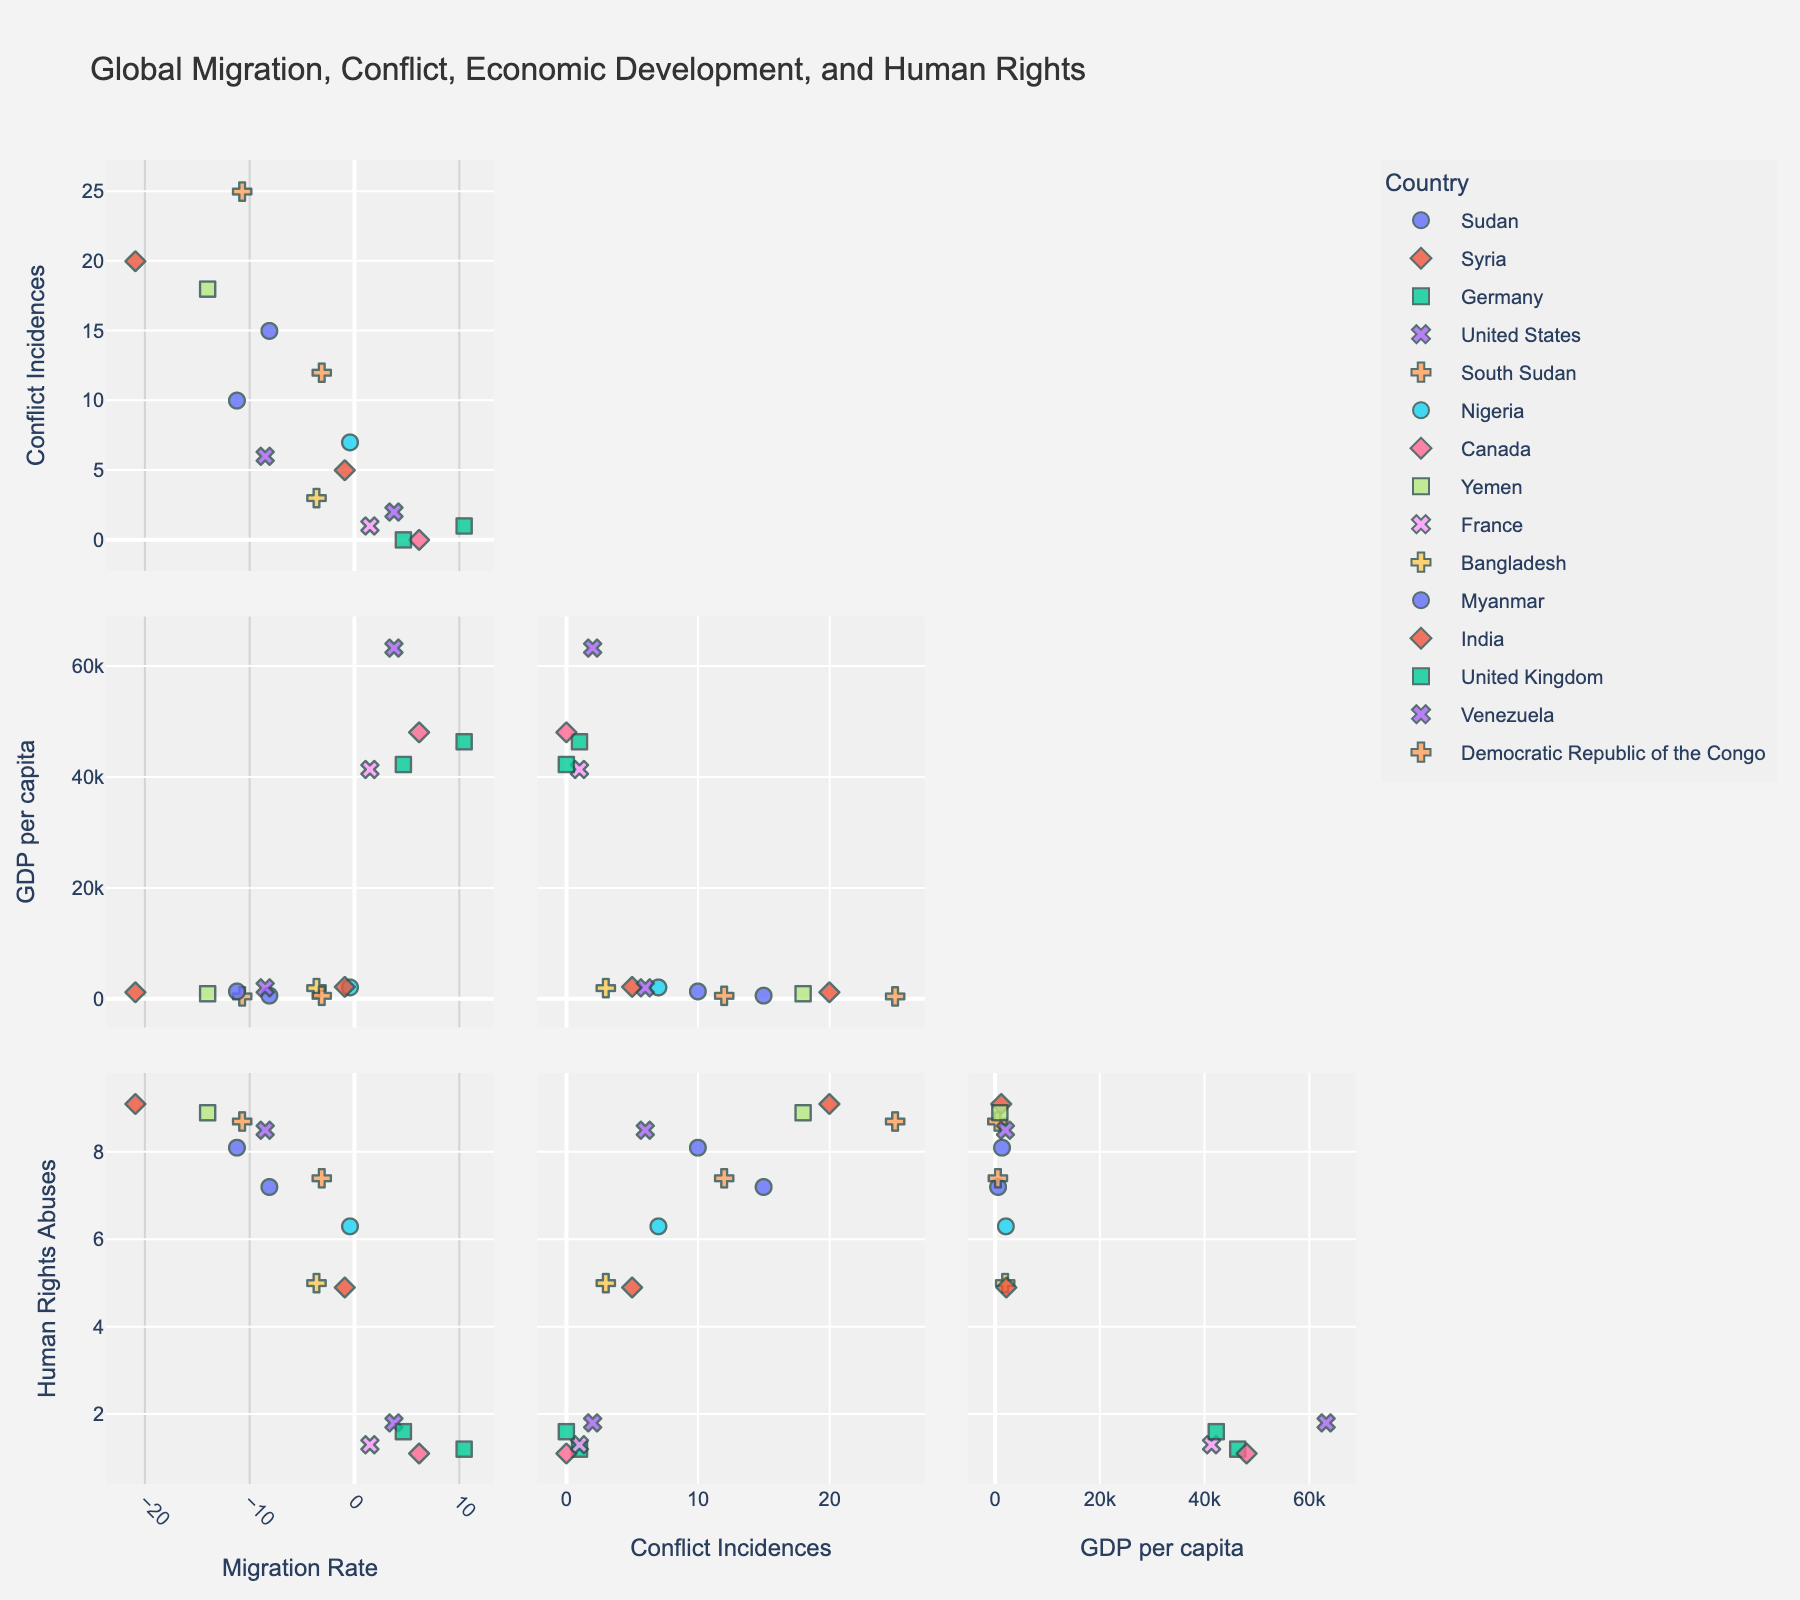What's the title of the figure? The title of the figure is generally placed at the top of the plot and is usually in a larger font size compared to the rest of the text.
Answer: Global Migration, Conflict, Economic Development, and Human Rights How many countries are represented in the figure? To count the number of countries represented, one needs to look at the unique colors or symbols in the scatter plot matrix. Each color or symbol corresponds to a different country.
Answer: 14 What country has the highest GDP per capita? To find the country with the highest GDP per capita, locate the 'GDP per capita (USD)' dimension and identify the data point that is furthest to the right.
Answer: United States Which country has the lowest migration rate? The lowest migration rate can be found by identifying the data point farthest to the left along the 'Migration Rate (per 1000)' axis.
Answer: Syria Is there a country with both low human rights abuses and high GDP per capita? Examine the scatter plot matrix for points where 'Human Rights Abuses (index)' is low (near the bottom axis) and 'GDP per capita (USD)' is high (near the right axis).
Answer: Yes, Germany and Canada What is the relationship between conflict incidences and human rights abuses for Sudan? Locate the data point representing Sudan in the scatter plots between 'Conflict Incidences (2021)' and 'Human Rights Abuses (index)' to see the trend. Sudan's position can then provide the needed insight.
Answer: Sudan has a high number of conflict incidences and a high human rights abuses index Compare the migration rate of Germany and Venezuela. Which is higher? Locate Germany and Venezuela in the 'Migration Rate (per 1000)' axis and compare their positions. The country further to the right has a higher migration rate.
Answer: Germany Does Yemen have a higher or lower GDP per capita compared to Myanmar? Identify the data points representing Yemen and Myanmar in the 'GDP per capita (USD)' dimension and compare their horizontal positions. The country further to the right has the higher GDP per capita.
Answer: Higher What's the average GDP per capita among countries with a negative migration rate? Identify the countries with negative migration rates (points to the left of the vertical axis) and calculate the average of their GDP per capita values.
Answer: (595 + 1200 + 458 + 940 + 1350 + 2000 + 561) / 7 = 1143.43 USD 